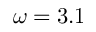Convert formula to latex. <formula><loc_0><loc_0><loc_500><loc_500>\omega = 3 . 1</formula> 